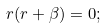Convert formula to latex. <formula><loc_0><loc_0><loc_500><loc_500>r ( r + \beta ) = 0 ;</formula> 